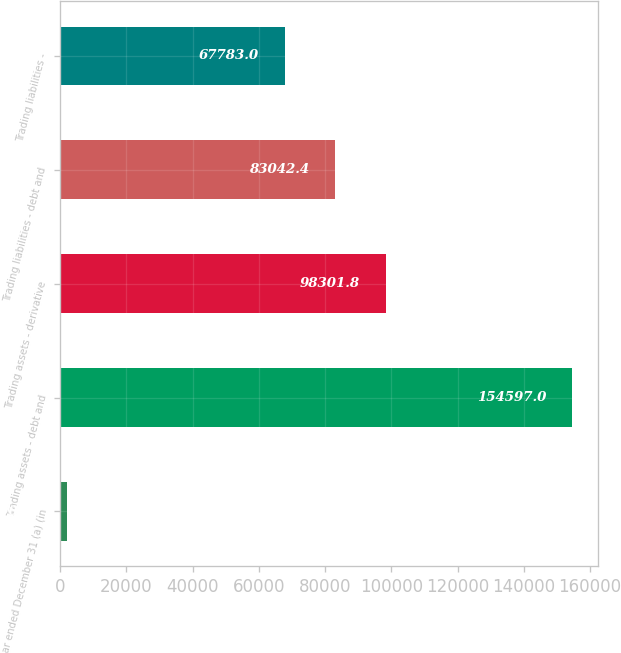<chart> <loc_0><loc_0><loc_500><loc_500><bar_chart><fcel>Year ended December 31 (a) (in<fcel>Trading assets - debt and<fcel>Trading assets - derivative<fcel>Trading liabilities - debt and<fcel>Trading liabilities -<nl><fcel>2003<fcel>154597<fcel>98301.8<fcel>83042.4<fcel>67783<nl></chart> 